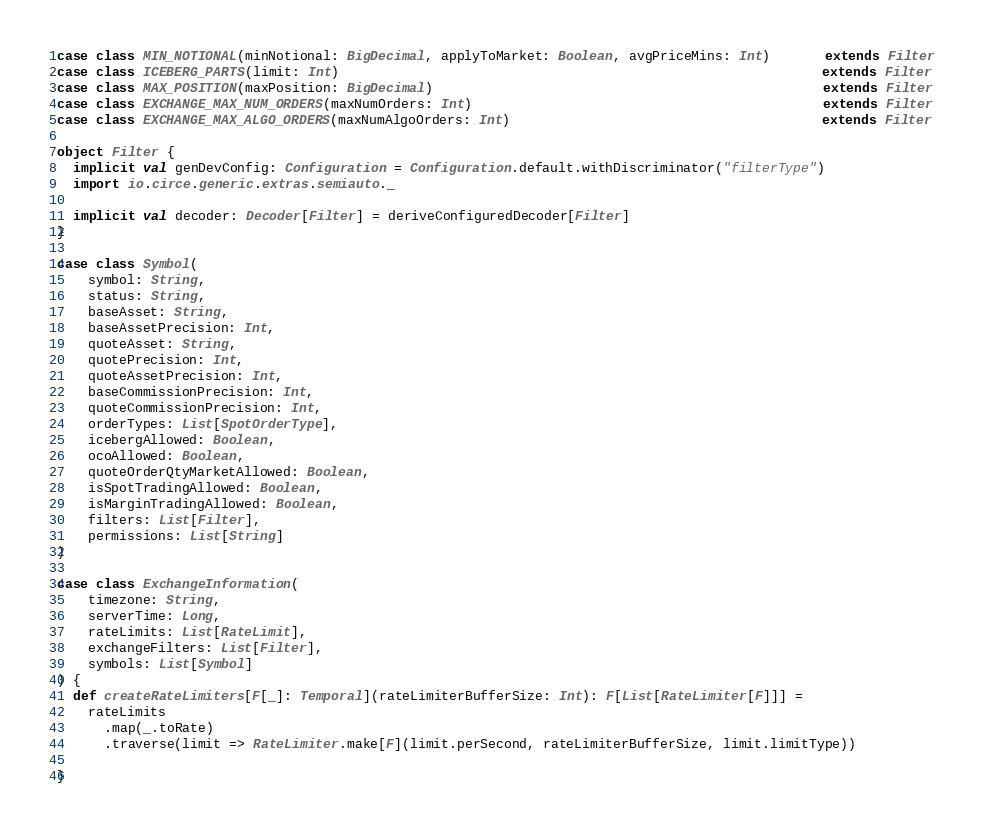<code> <loc_0><loc_0><loc_500><loc_500><_Scala_>case class MIN_NOTIONAL(minNotional: BigDecimal, applyToMarket: Boolean, avgPriceMins: Int)       extends Filter
case class ICEBERG_PARTS(limit: Int)                                                              extends Filter
case class MAX_POSITION(maxPosition: BigDecimal)                                                  extends Filter
case class EXCHANGE_MAX_NUM_ORDERS(maxNumOrders: Int)                                             extends Filter
case class EXCHANGE_MAX_ALGO_ORDERS(maxNumAlgoOrders: Int)                                        extends Filter

object Filter {
  implicit val genDevConfig: Configuration = Configuration.default.withDiscriminator("filterType")
  import io.circe.generic.extras.semiauto._

  implicit val decoder: Decoder[Filter] = deriveConfiguredDecoder[Filter]
}

case class Symbol(
    symbol: String,
    status: String,
    baseAsset: String,
    baseAssetPrecision: Int,
    quoteAsset: String,
    quotePrecision: Int,
    quoteAssetPrecision: Int,
    baseCommissionPrecision: Int,
    quoteCommissionPrecision: Int,
    orderTypes: List[SpotOrderType],
    icebergAllowed: Boolean,
    ocoAllowed: Boolean,
    quoteOrderQtyMarketAllowed: Boolean,
    isSpotTradingAllowed: Boolean,
    isMarginTradingAllowed: Boolean,
    filters: List[Filter],
    permissions: List[String]
)

case class ExchangeInformation(
    timezone: String,
    serverTime: Long,
    rateLimits: List[RateLimit],
    exchangeFilters: List[Filter],
    symbols: List[Symbol]
) {
  def createRateLimiters[F[_]: Temporal](rateLimiterBufferSize: Int): F[List[RateLimiter[F]]] =
    rateLimits
      .map(_.toRate)
      .traverse(limit => RateLimiter.make[F](limit.perSecond, rateLimiterBufferSize, limit.limitType))

}
</code> 